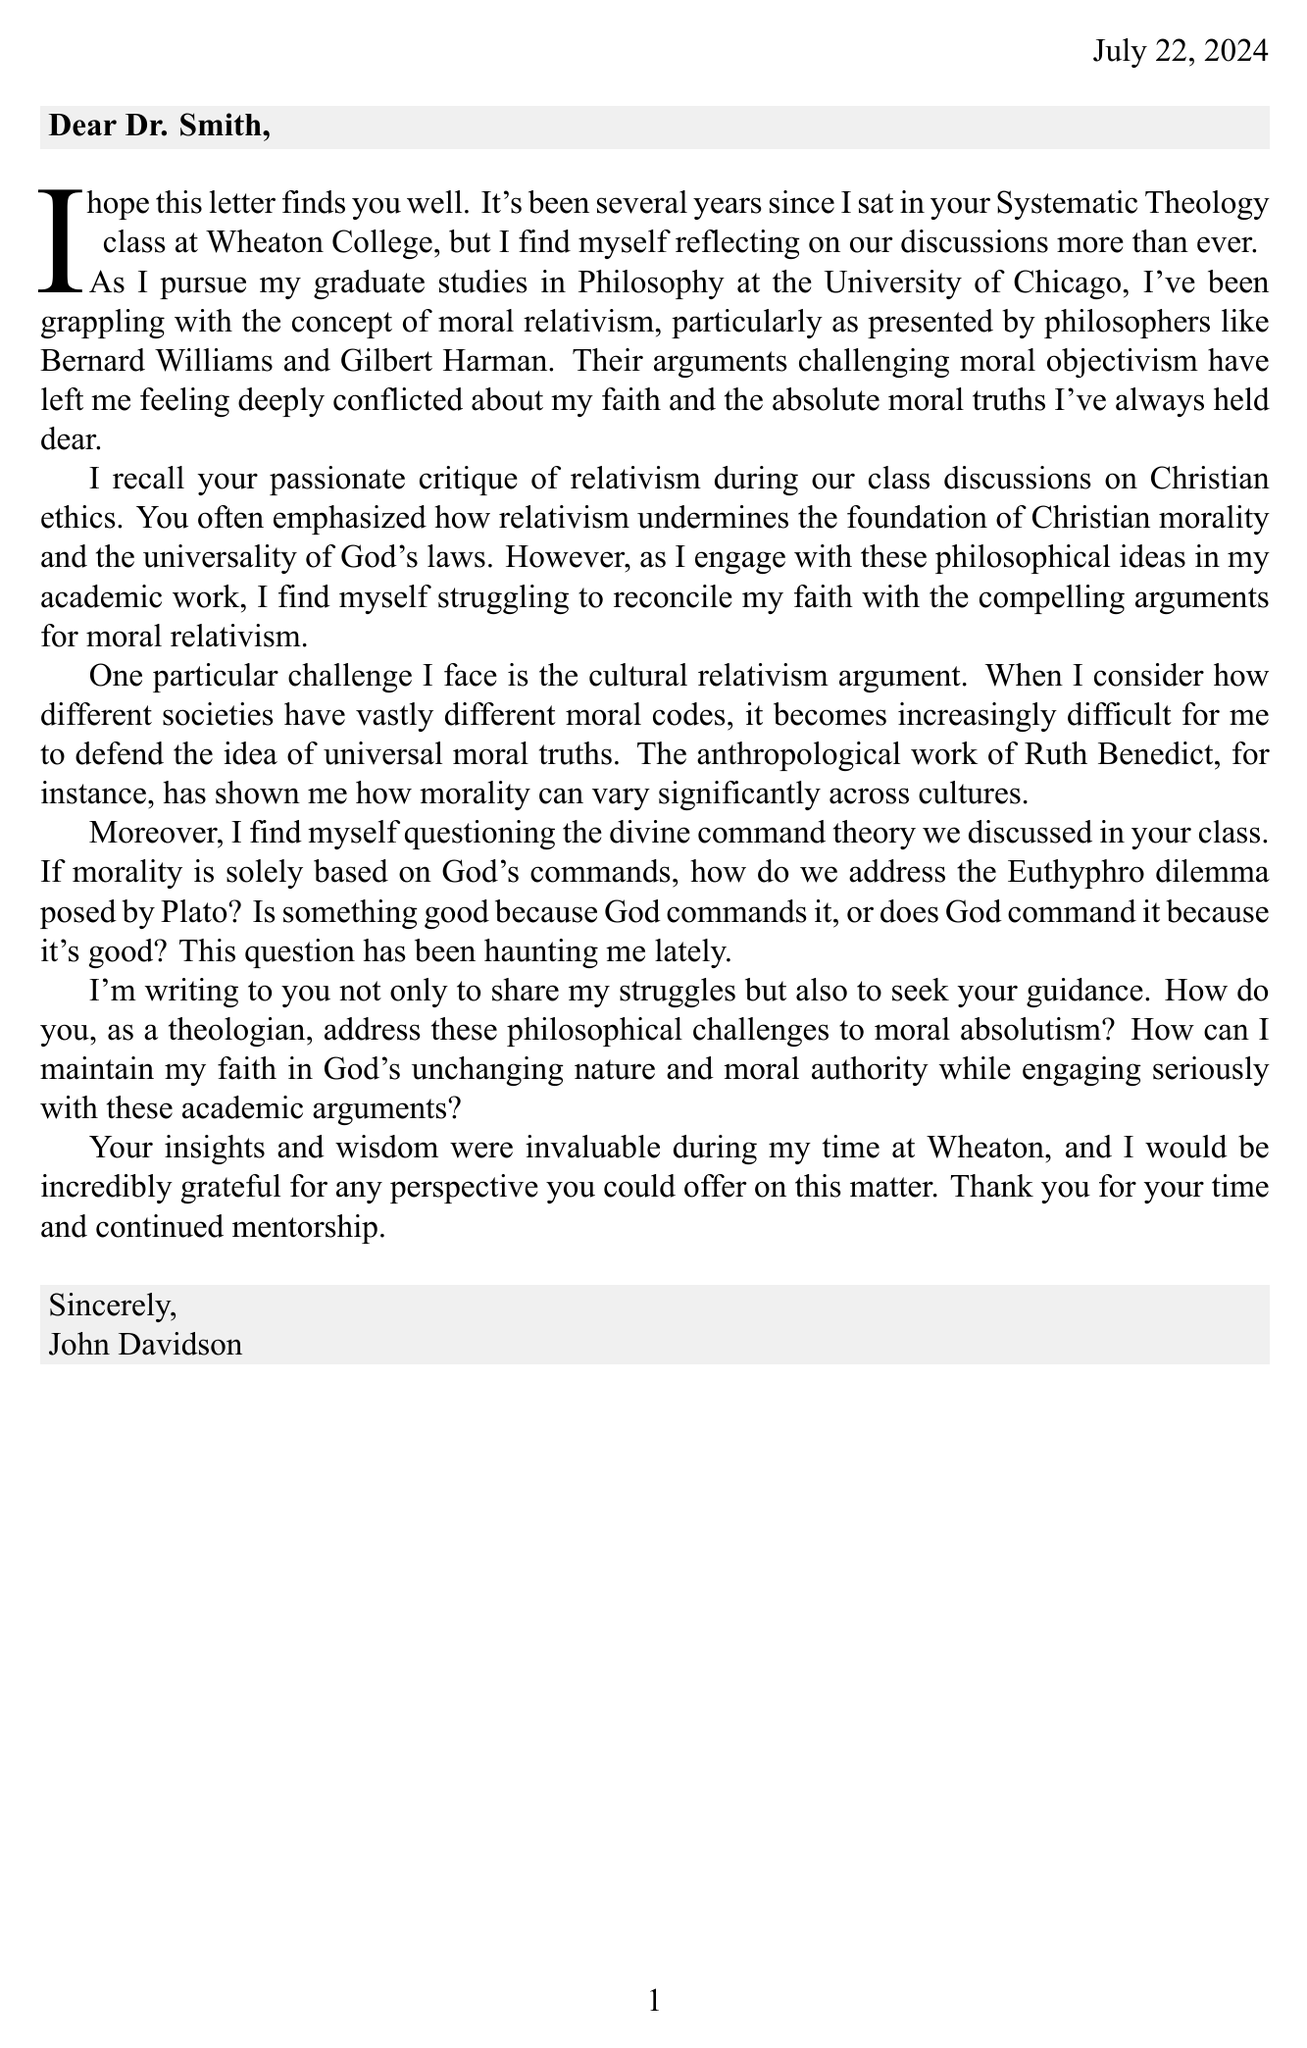What is the name of the former student? The letter states that the sender is John Davidson, a former student of Dr. Smith.
Answer: John Davidson Which university is the former student attending for graduate studies? The document mentions that John Davidson is pursuing his graduate studies at the University of Chicago.
Answer: University of Chicago Who are the two philosophers mentioned in the letter? The student references Bernard Williams and Gilbert Harman while discussing moral relativism.
Answer: Bernard Williams, Gilbert Harman What particular theory does the student question in relation to God's commands? The student expresses doubt about the divine command theory discussed in class.
Answer: Divine command theory What philosophical issue is described as haunting the student? The letter highlights the Euthyphro dilemma as a significant philosophical issue for the student.
Answer: Euthyphro dilemma What ethical topic was a primary focus in Dr. Smith's Systematic Theology class? The student recalls that Christian ethics was a topic of passionate discussion and critique regarding relativism.
Answer: Christian ethics What anthropologist's work is mentioned concerning moral codes across cultures? The student cites Ruth Benedict's anthropological work when discussing cultural differences in morality.
Answer: Ruth Benedict What is the student's main request in the letter? The letter expresses a desire for guidance from Dr. Smith on reconciling faith with philosophical challenges.
Answer: Guidance 